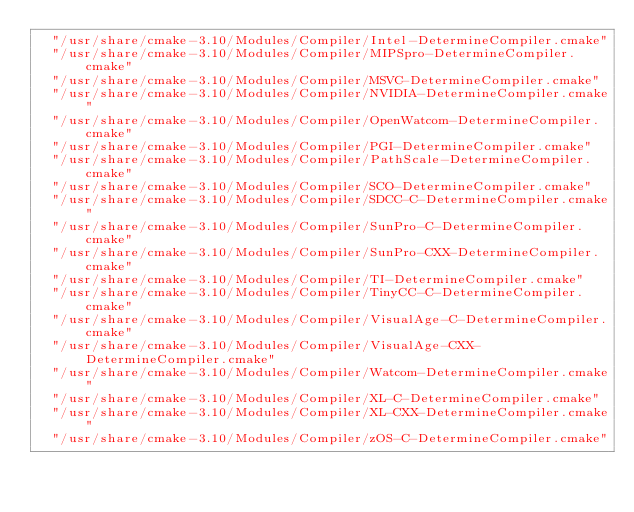Convert code to text. <code><loc_0><loc_0><loc_500><loc_500><_CMake_>  "/usr/share/cmake-3.10/Modules/Compiler/Intel-DetermineCompiler.cmake"
  "/usr/share/cmake-3.10/Modules/Compiler/MIPSpro-DetermineCompiler.cmake"
  "/usr/share/cmake-3.10/Modules/Compiler/MSVC-DetermineCompiler.cmake"
  "/usr/share/cmake-3.10/Modules/Compiler/NVIDIA-DetermineCompiler.cmake"
  "/usr/share/cmake-3.10/Modules/Compiler/OpenWatcom-DetermineCompiler.cmake"
  "/usr/share/cmake-3.10/Modules/Compiler/PGI-DetermineCompiler.cmake"
  "/usr/share/cmake-3.10/Modules/Compiler/PathScale-DetermineCompiler.cmake"
  "/usr/share/cmake-3.10/Modules/Compiler/SCO-DetermineCompiler.cmake"
  "/usr/share/cmake-3.10/Modules/Compiler/SDCC-C-DetermineCompiler.cmake"
  "/usr/share/cmake-3.10/Modules/Compiler/SunPro-C-DetermineCompiler.cmake"
  "/usr/share/cmake-3.10/Modules/Compiler/SunPro-CXX-DetermineCompiler.cmake"
  "/usr/share/cmake-3.10/Modules/Compiler/TI-DetermineCompiler.cmake"
  "/usr/share/cmake-3.10/Modules/Compiler/TinyCC-C-DetermineCompiler.cmake"
  "/usr/share/cmake-3.10/Modules/Compiler/VisualAge-C-DetermineCompiler.cmake"
  "/usr/share/cmake-3.10/Modules/Compiler/VisualAge-CXX-DetermineCompiler.cmake"
  "/usr/share/cmake-3.10/Modules/Compiler/Watcom-DetermineCompiler.cmake"
  "/usr/share/cmake-3.10/Modules/Compiler/XL-C-DetermineCompiler.cmake"
  "/usr/share/cmake-3.10/Modules/Compiler/XL-CXX-DetermineCompiler.cmake"
  "/usr/share/cmake-3.10/Modules/Compiler/zOS-C-DetermineCompiler.cmake"</code> 